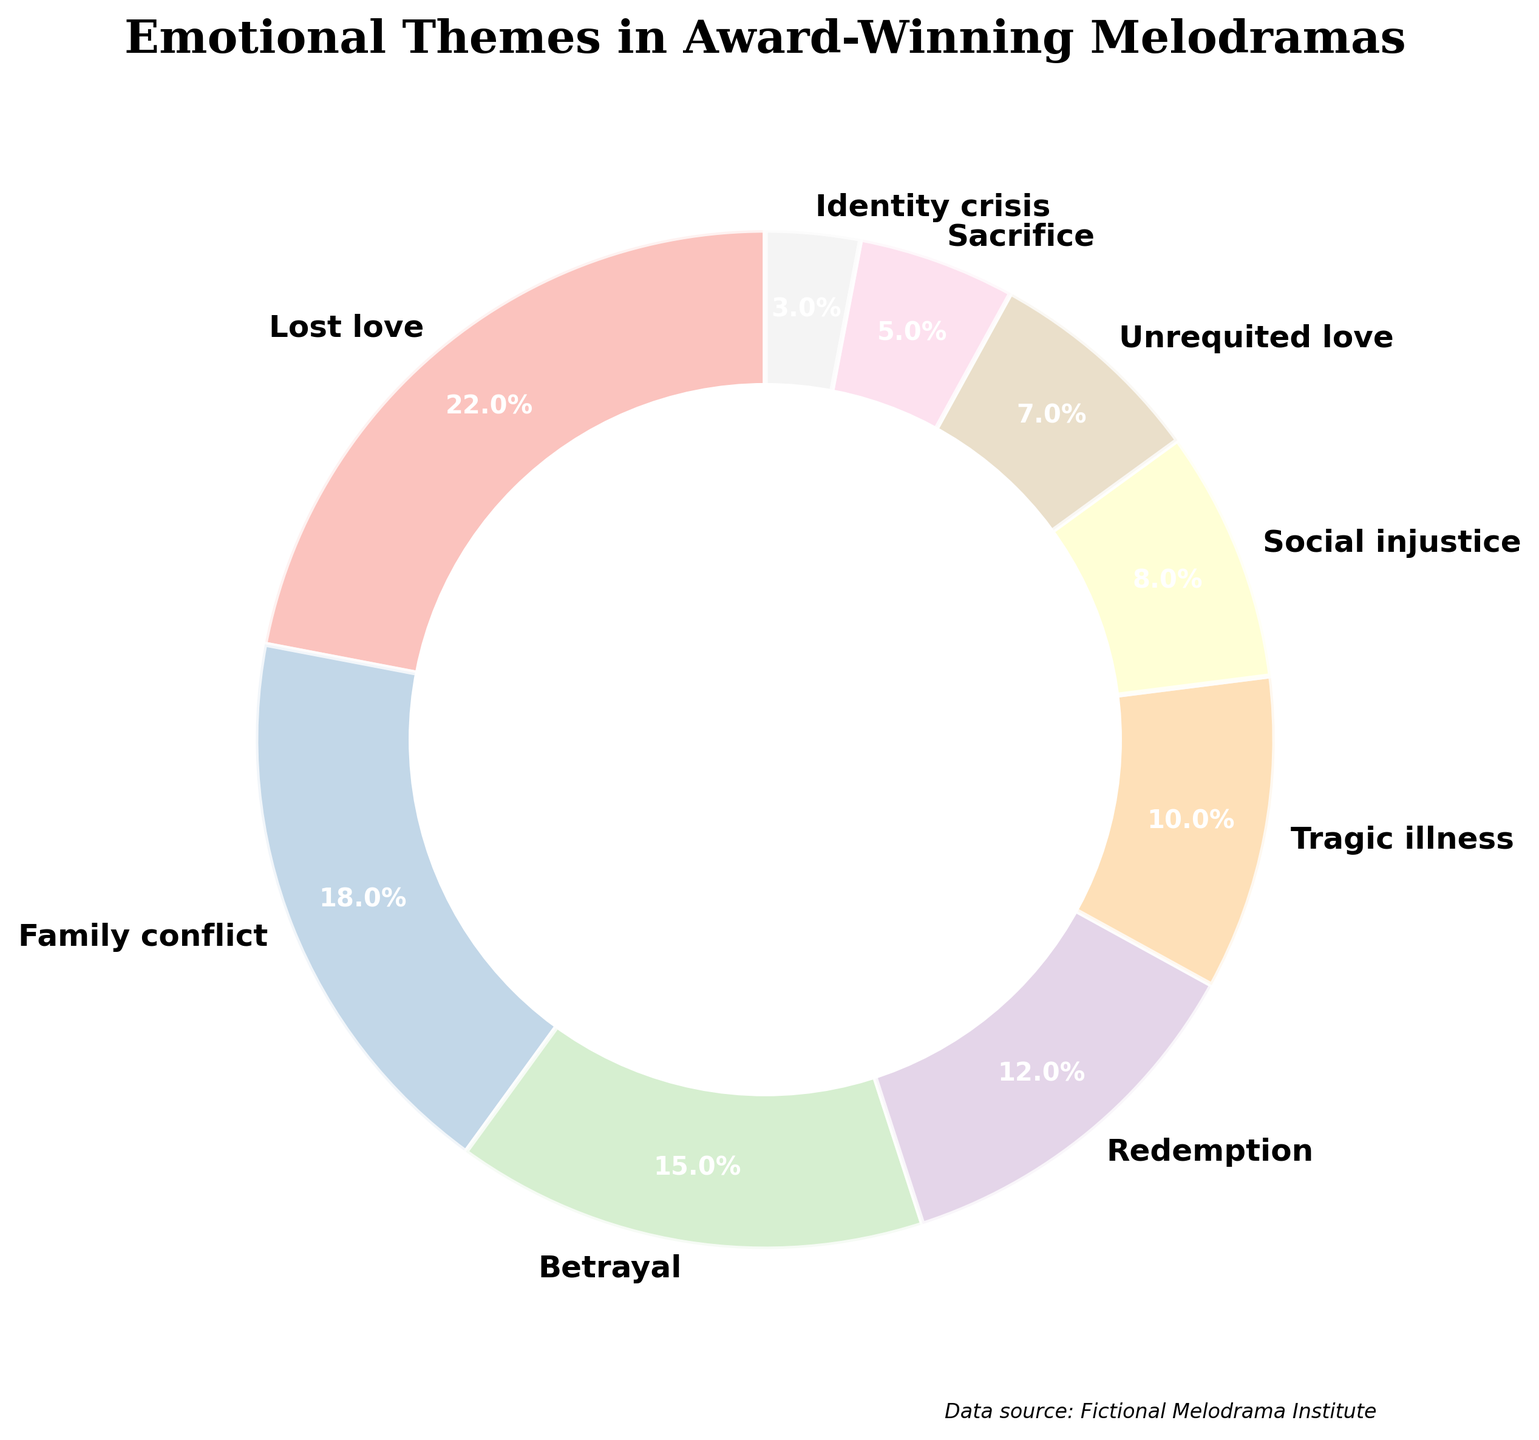What theme constitutes the largest portion of the emotional themes in award-winning melodramas? By examining the percentage values on the plot, the largest portion is for the theme with the highest percentage. According to the figure, "Lost love" has the highest percentage at 22%.
Answer: Lost love Which emotional theme has exactly half the percentage of the 'Family conflict' theme? The percentage of the 'Family conflict' theme is 18%. Half of 18% is 9%. Looking at the figure, no theme has exactly 9%, so there is no direct answer based on the given options.
Answer: None Compare the total percentages of 'Redemption' and 'Tragic illness' with 'Lost love'. Which is greater? Summing the percentages of 'Redemption' (12%) and 'Tragic illness' (10%) gives a total of 22%. The percentage for 'Lost love' is also 22%. So they are equal.
Answer: They are equal What theme appears in bright colors such as light blue or pink? Referring to the visual attributes like the lighter shades in the pastel color palette used, "Lost love" and "Betrayal" show lighter colors such as light blue and pink.
Answer: Lost love and Betrayal How does the percentage of 'Sacrifice' compare to the total percentage of 'Social injustice' and 'Unrequited love'? The percentages for 'Social injustice' and 'Unrequited love' are 8% and 7%, respectively, summing to 15%. The percentage for 'Sacrifice' is 5%, which is less than the 15% sum of 'Social injustice' and 'Unrequited love'.
Answer: Less than What are the themes that have a percentage of less than 10%? By looking at the figure, the themes with less than 10% are 'Social injustice' (8%), 'Unrequited love' (7%), 'Sacrifice' (5%), and 'Identity crisis' (3%).
Answer: Social injustice, Unrequited love, Sacrifice, Identity crisis What percentage of the total is taken up by 'Family conflict' and 'Betrayal' together? The percentage for 'Family conflict' is 18% and 'Betrayal' is 15%. Adding these together gives 18% + 15% = 33%.
Answer: 33% Which theme has the least representation in the pie chart? By examining the smallest percentage in the figure, 'Identity crisis' has the least representation with 3%.
Answer: Identity crisis If 'Lost love' and 'Family conflict' were combined into one category, what would their total percentage be? Summing the percentages of 'Lost love' (22%) and 'Family conflict' (18%) gives a total of 22% + 18% = 40%.
Answer: 40% Is the total percentage for 'Redemption', 'Tragic illness', and 'Sacrifice' greater than or less than 30%? Adding the percentages for 'Redemption' (12%), 'Tragic illness' (10%), and 'Sacrifice' (5%) gives a total of 12% + 10% + 5% = 27%, which is less than 30%.
Answer: Less than 30% 